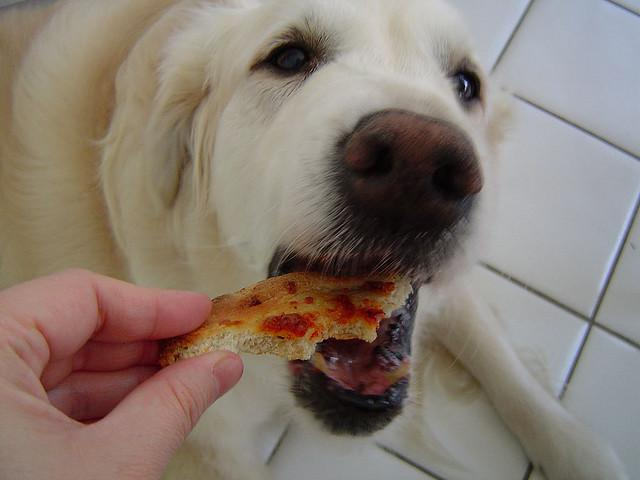What is the dog chowing down on? pizza 